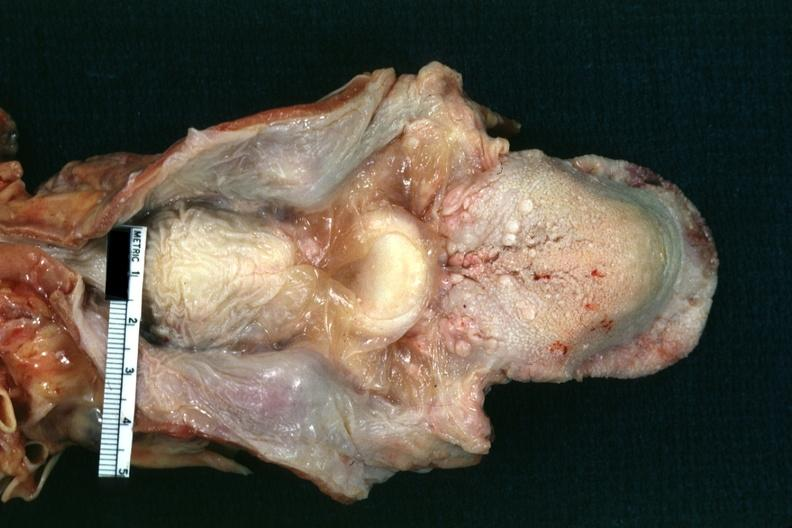what is present?
Answer the question using a single word or phrase. Larynx 